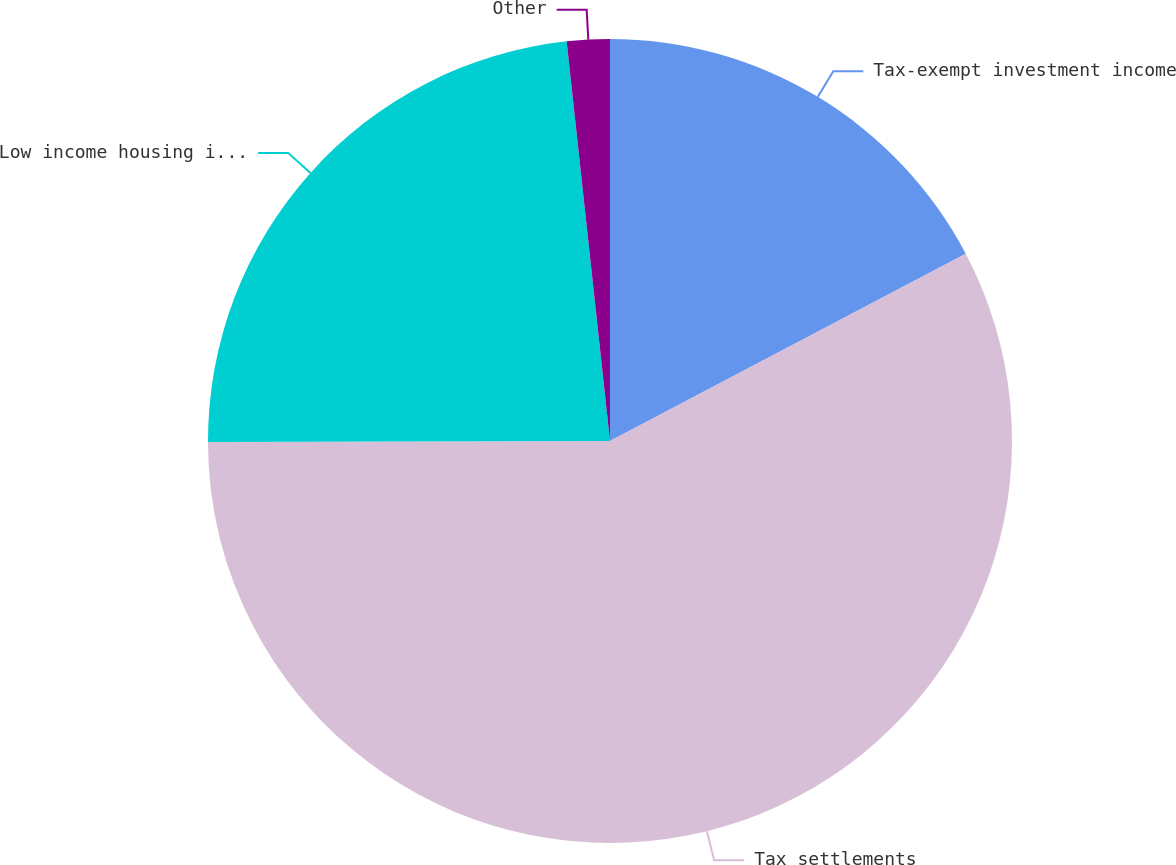Convert chart. <chart><loc_0><loc_0><loc_500><loc_500><pie_chart><fcel>Tax-exempt investment income<fcel>Tax settlements<fcel>Low income housing investments<fcel>Other<nl><fcel>17.29%<fcel>57.67%<fcel>23.32%<fcel>1.72%<nl></chart> 